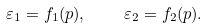Convert formula to latex. <formula><loc_0><loc_0><loc_500><loc_500>\varepsilon _ { 1 } = f _ { 1 } ( p ) , \quad \varepsilon _ { 2 } = f _ { 2 } ( p ) .</formula> 